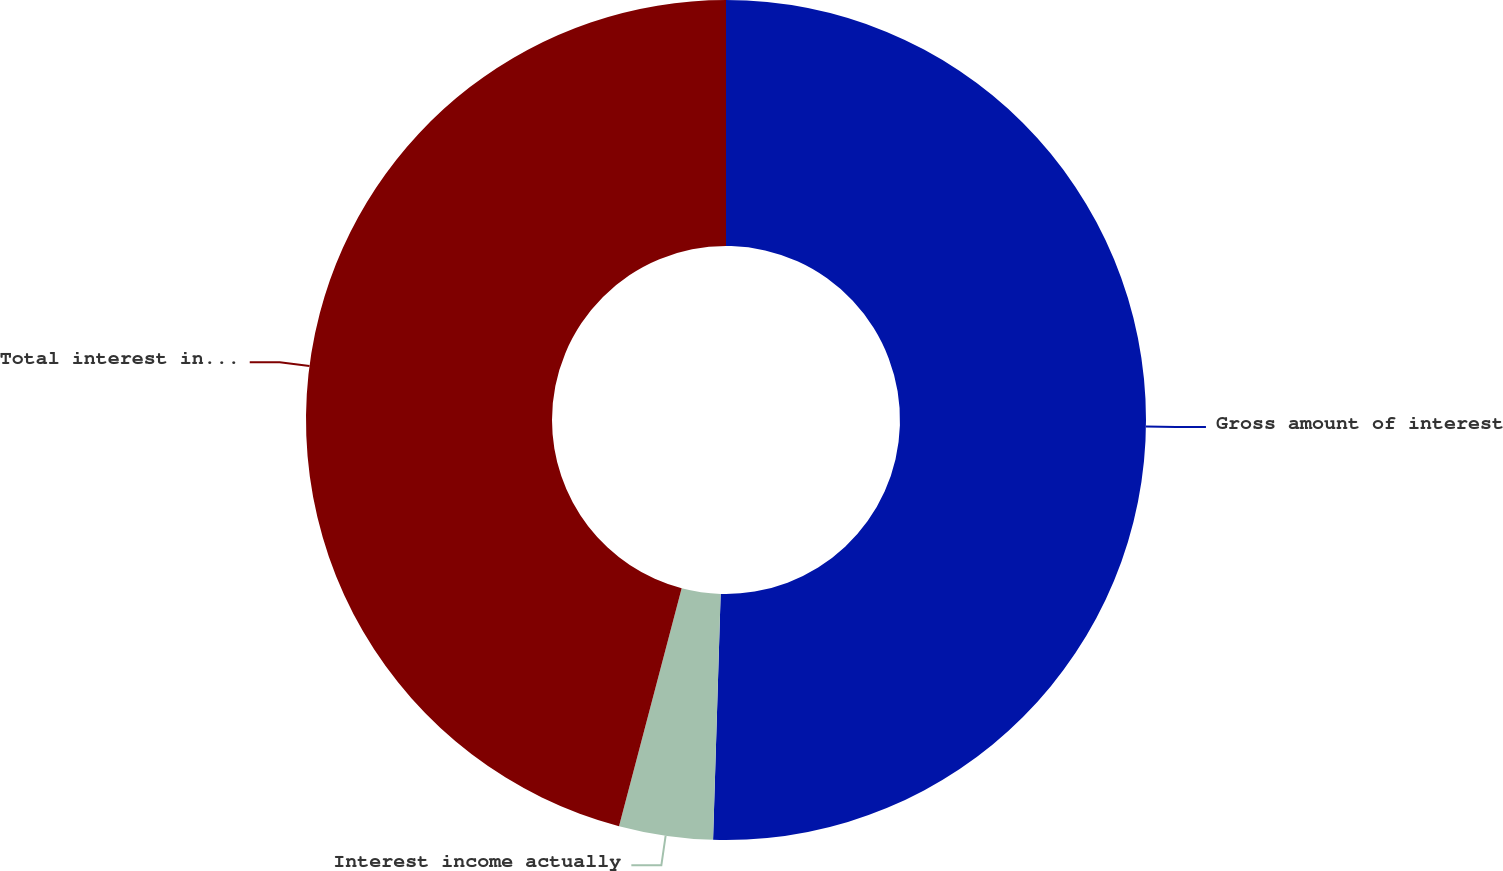Convert chart. <chart><loc_0><loc_0><loc_500><loc_500><pie_chart><fcel>Gross amount of interest<fcel>Interest income actually<fcel>Total interest income foregone<nl><fcel>50.49%<fcel>3.61%<fcel>45.9%<nl></chart> 